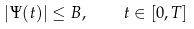Convert formula to latex. <formula><loc_0><loc_0><loc_500><loc_500>| \Psi ( t ) | \leq B , \quad t \in [ 0 , T ]</formula> 